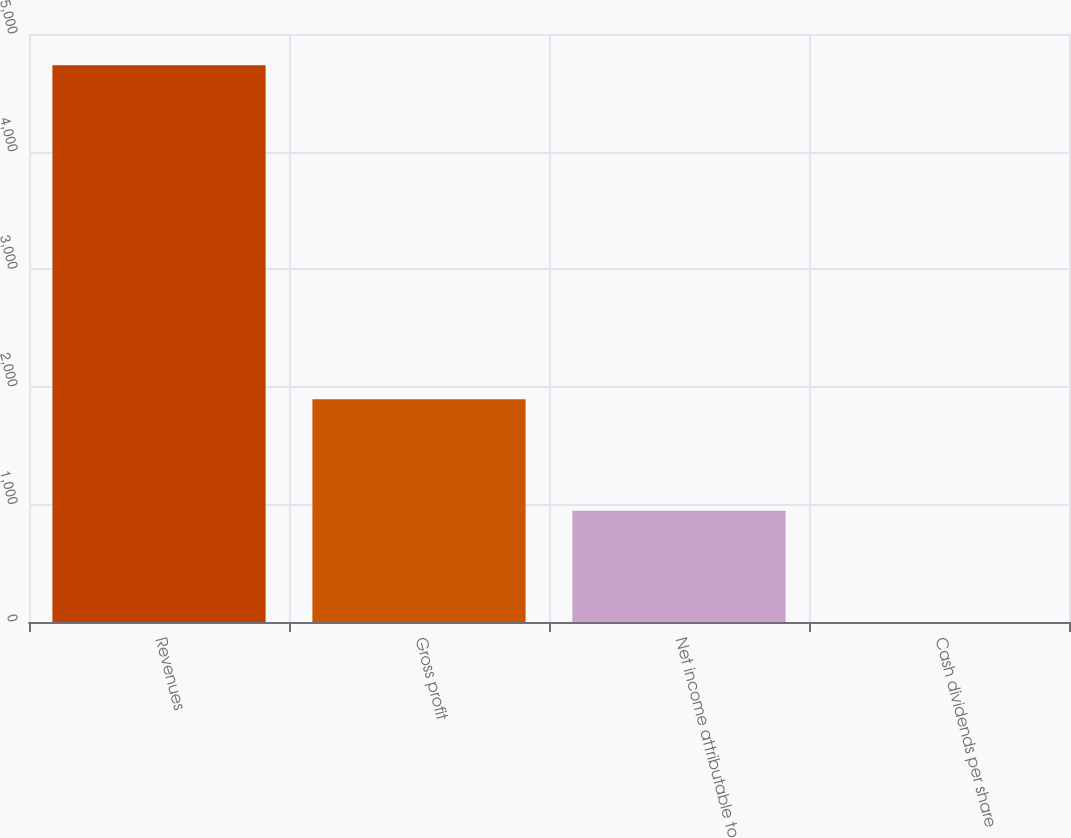Convert chart. <chart><loc_0><loc_0><loc_500><loc_500><bar_chart><fcel>Revenues<fcel>Gross profit<fcel>Net income attributable to<fcel>Cash dividends per share<nl><fcel>4734<fcel>1893.68<fcel>946.9<fcel>0.12<nl></chart> 